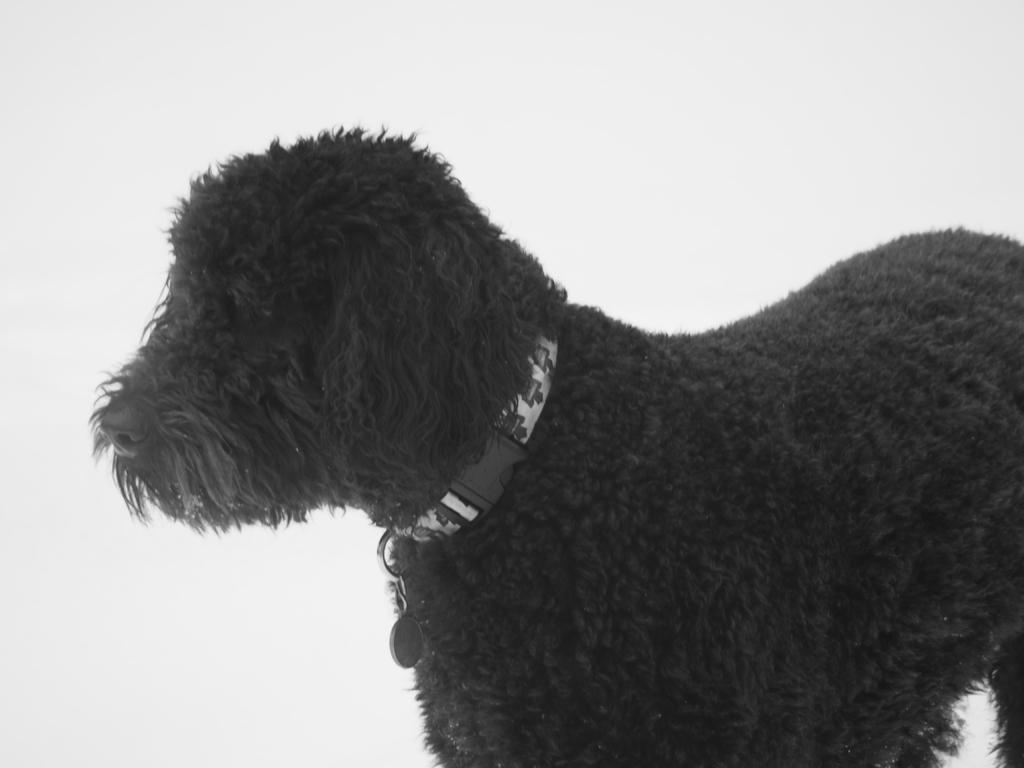Could you give a brief overview of what you see in this image? In the image I can see a black color dog which has a dog neck belt. The background of the image is white in color. 